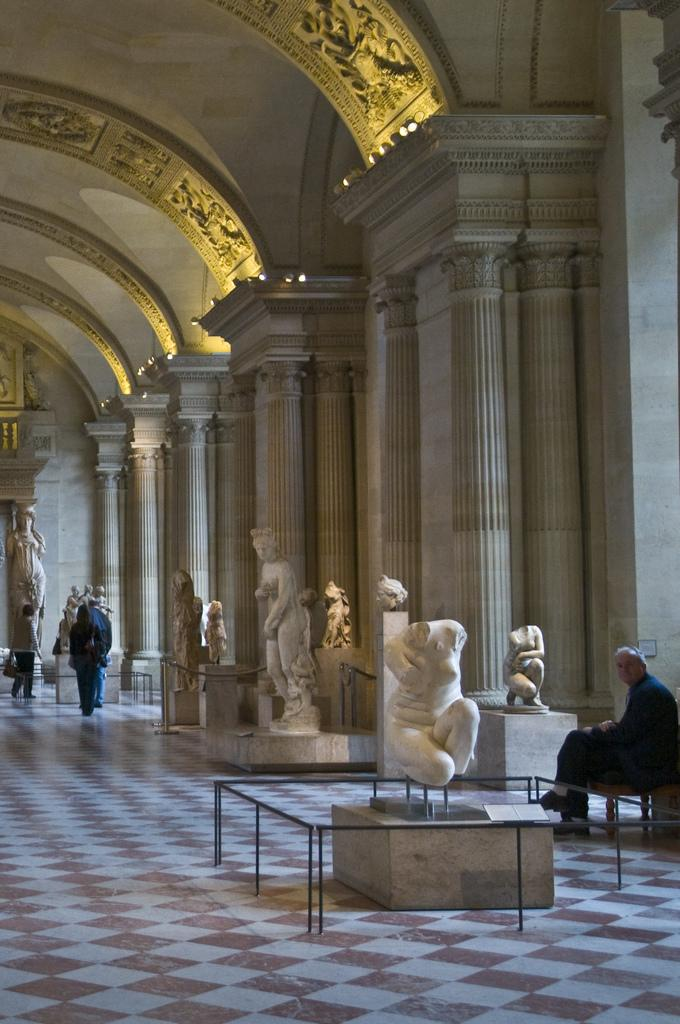What type of structures can be seen in the image? There are statues and pillars in the image. What are the people in the image doing? There are people walking and one person sitting in the image. What can be used to provide illumination in the image? There are lights visible in the image. Where is the hole in the image? There is no hole present in the image. What type of hand is visible in the image? There are no hands visible in the image. 